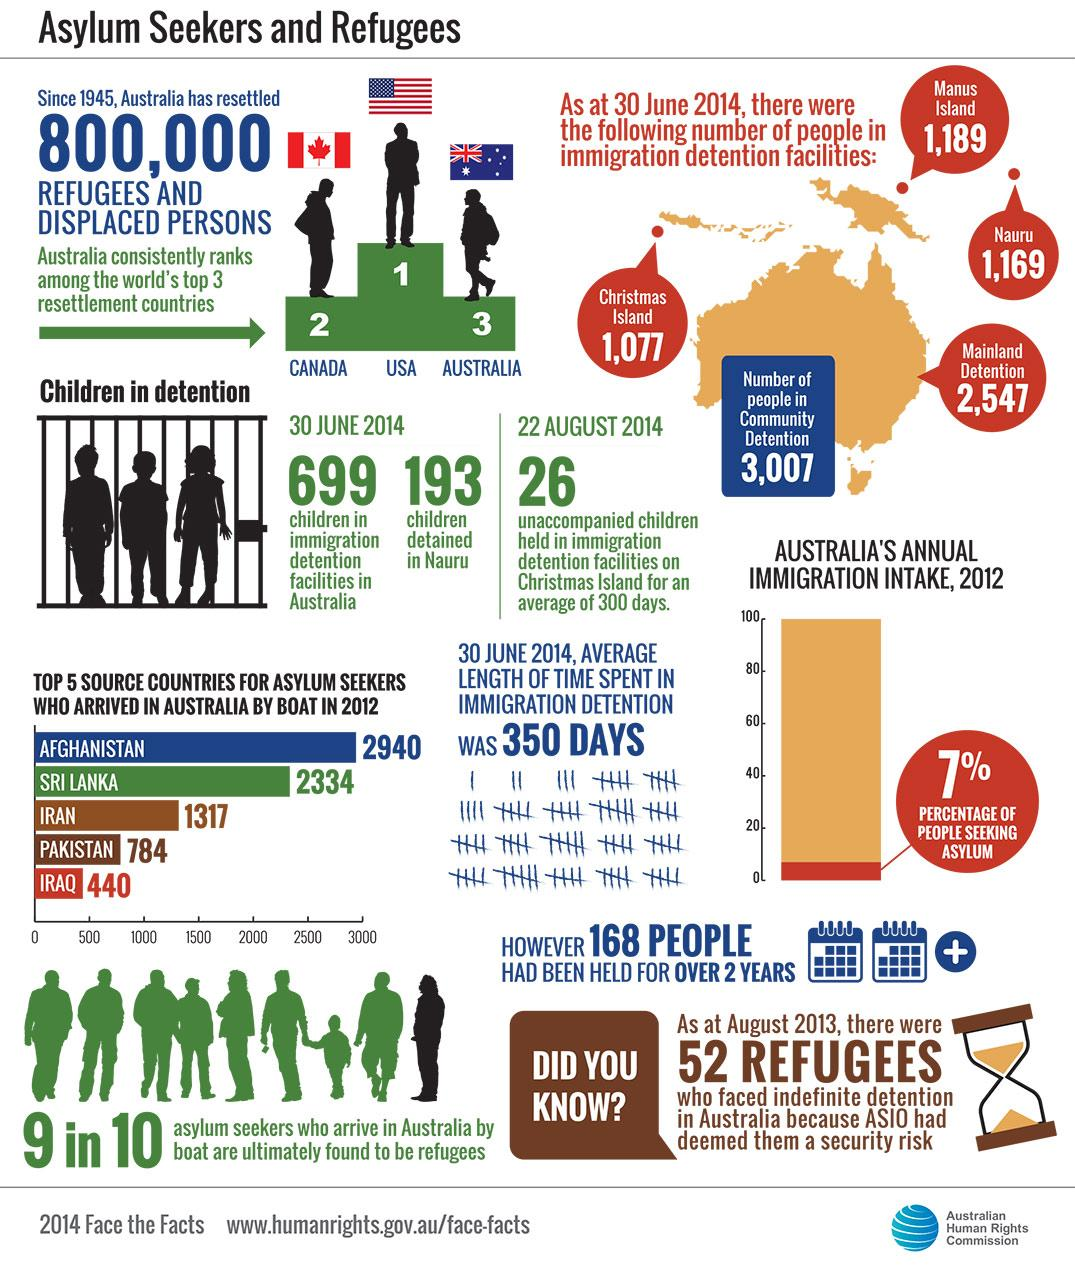Highlight a few significant elements in this photo. In 2012, 1,317 asylum seekers from Iran arrived in Australia by boat. Pakistan was forced to send a record 784 asylum seekers to Australia by boat in 2012. In 2012, a total of 2334 asylum seekers from Sri Lanka arrived in Australia by boat. On June 30th, 2014, a total of 193 children were detained on Nauru. In 2012, Afghanistan had to send 2,940 asylum seekers to Australia by boat. 